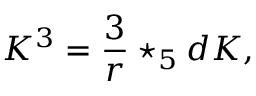<formula> <loc_0><loc_0><loc_500><loc_500>K ^ { 3 } = { \frac { 3 } { r } } ^ { * } _ { 5 } d K ,</formula> 